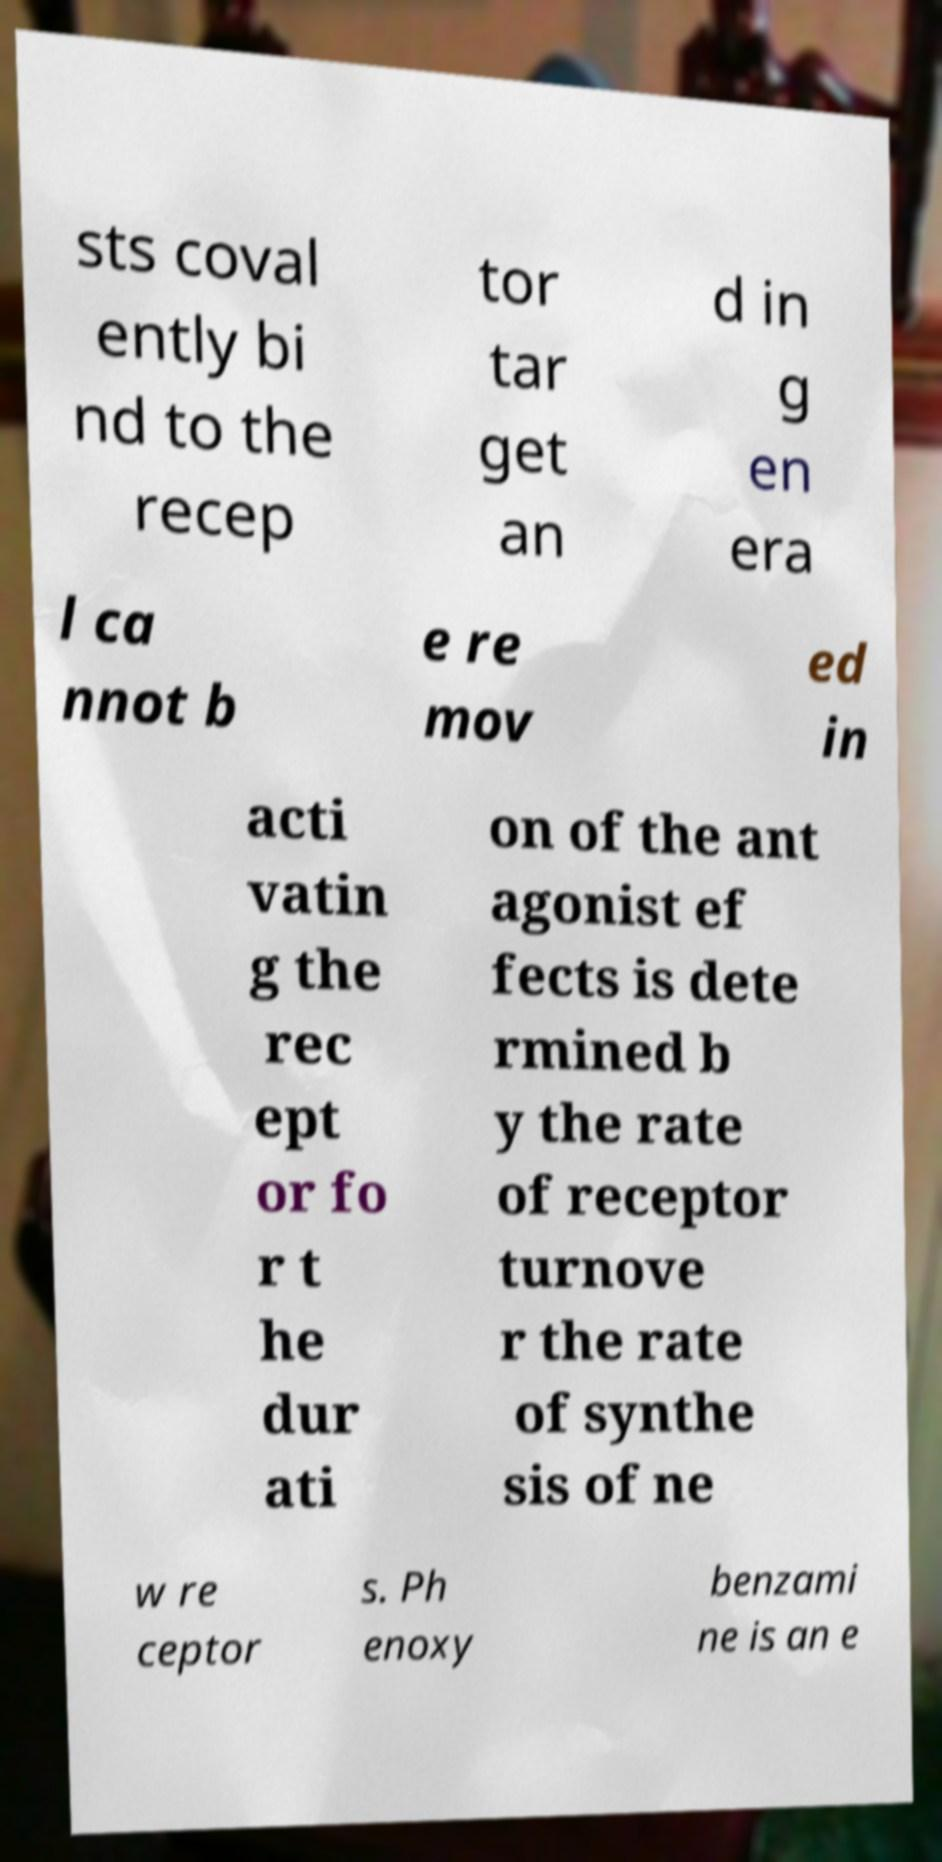Can you accurately transcribe the text from the provided image for me? sts coval ently bi nd to the recep tor tar get an d in g en era l ca nnot b e re mov ed in acti vatin g the rec ept or fo r t he dur ati on of the ant agonist ef fects is dete rmined b y the rate of receptor turnove r the rate of synthe sis of ne w re ceptor s. Ph enoxy benzami ne is an e 